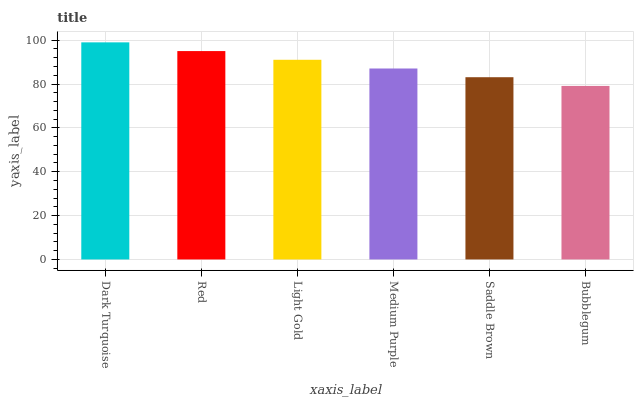Is Bubblegum the minimum?
Answer yes or no. Yes. Is Dark Turquoise the maximum?
Answer yes or no. Yes. Is Red the minimum?
Answer yes or no. No. Is Red the maximum?
Answer yes or no. No. Is Dark Turquoise greater than Red?
Answer yes or no. Yes. Is Red less than Dark Turquoise?
Answer yes or no. Yes. Is Red greater than Dark Turquoise?
Answer yes or no. No. Is Dark Turquoise less than Red?
Answer yes or no. No. Is Light Gold the high median?
Answer yes or no. Yes. Is Medium Purple the low median?
Answer yes or no. Yes. Is Dark Turquoise the high median?
Answer yes or no. No. Is Saddle Brown the low median?
Answer yes or no. No. 